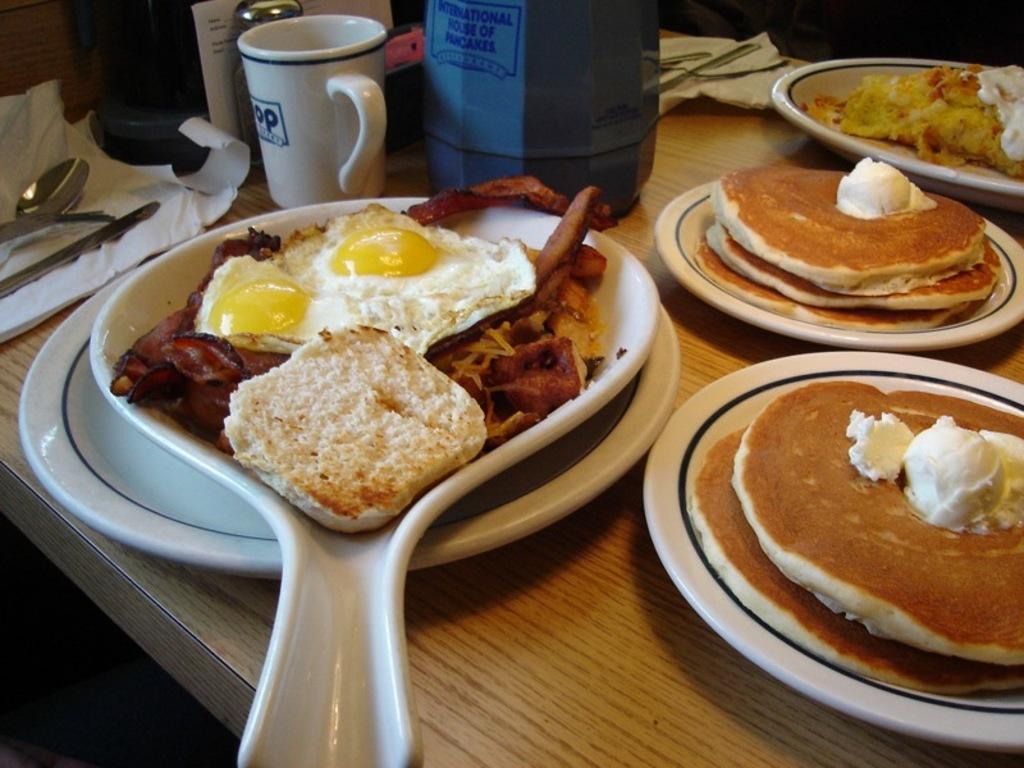Can you describe this image briefly? In this image we can see a table. On the table there are many serving plates. In the serving plates we can see pancakes topped with ice cream, omelette, bacon and bread. Beside the serving plates we can see pet jar, coffee mug, sprinkler, tissue paper and cutlery. 